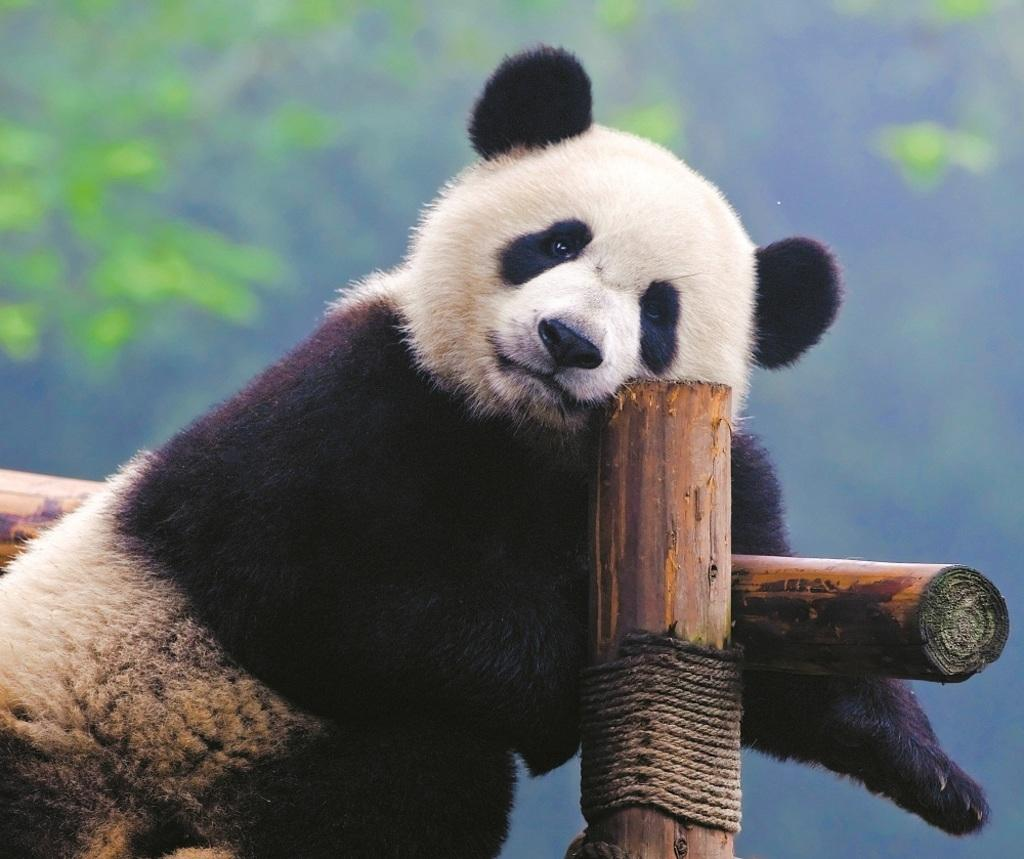What type of animal can be seen in the image? There is an animal in the image, but its specific type cannot be determined from the provided facts. What colors are present on the animal in the image? The animal is in brown and cream color. What objects are present in the image besides the animal? There are wooden logs in the image. What can be seen in the background of the image? There are plants in the background of the image, and they are green in color. What is the condition of the ghost in the image? There is no ghost present in the image; it only features an animal, wooden logs, and plants in the background. 